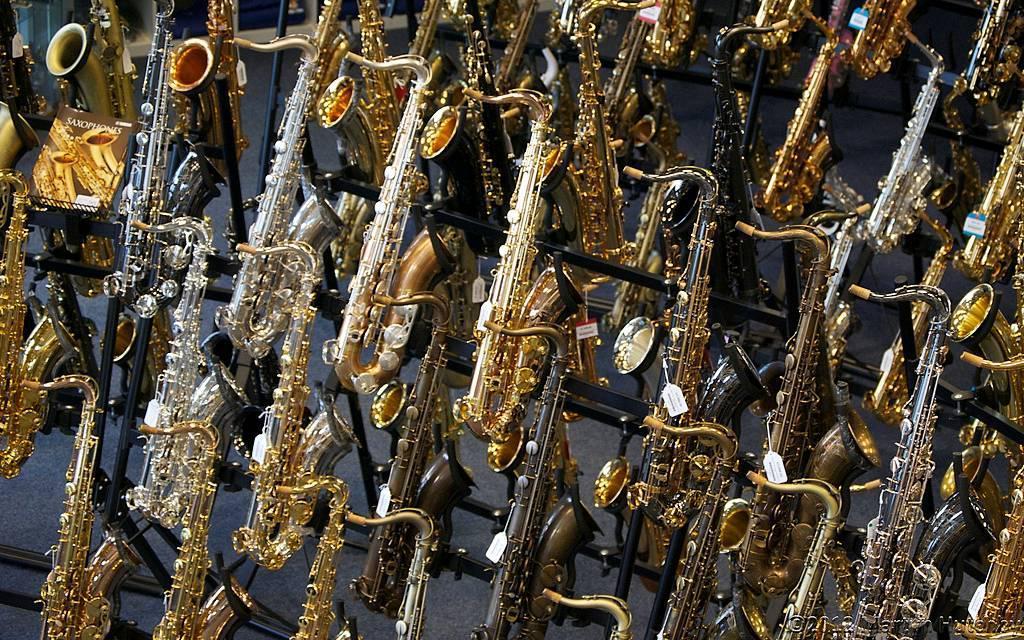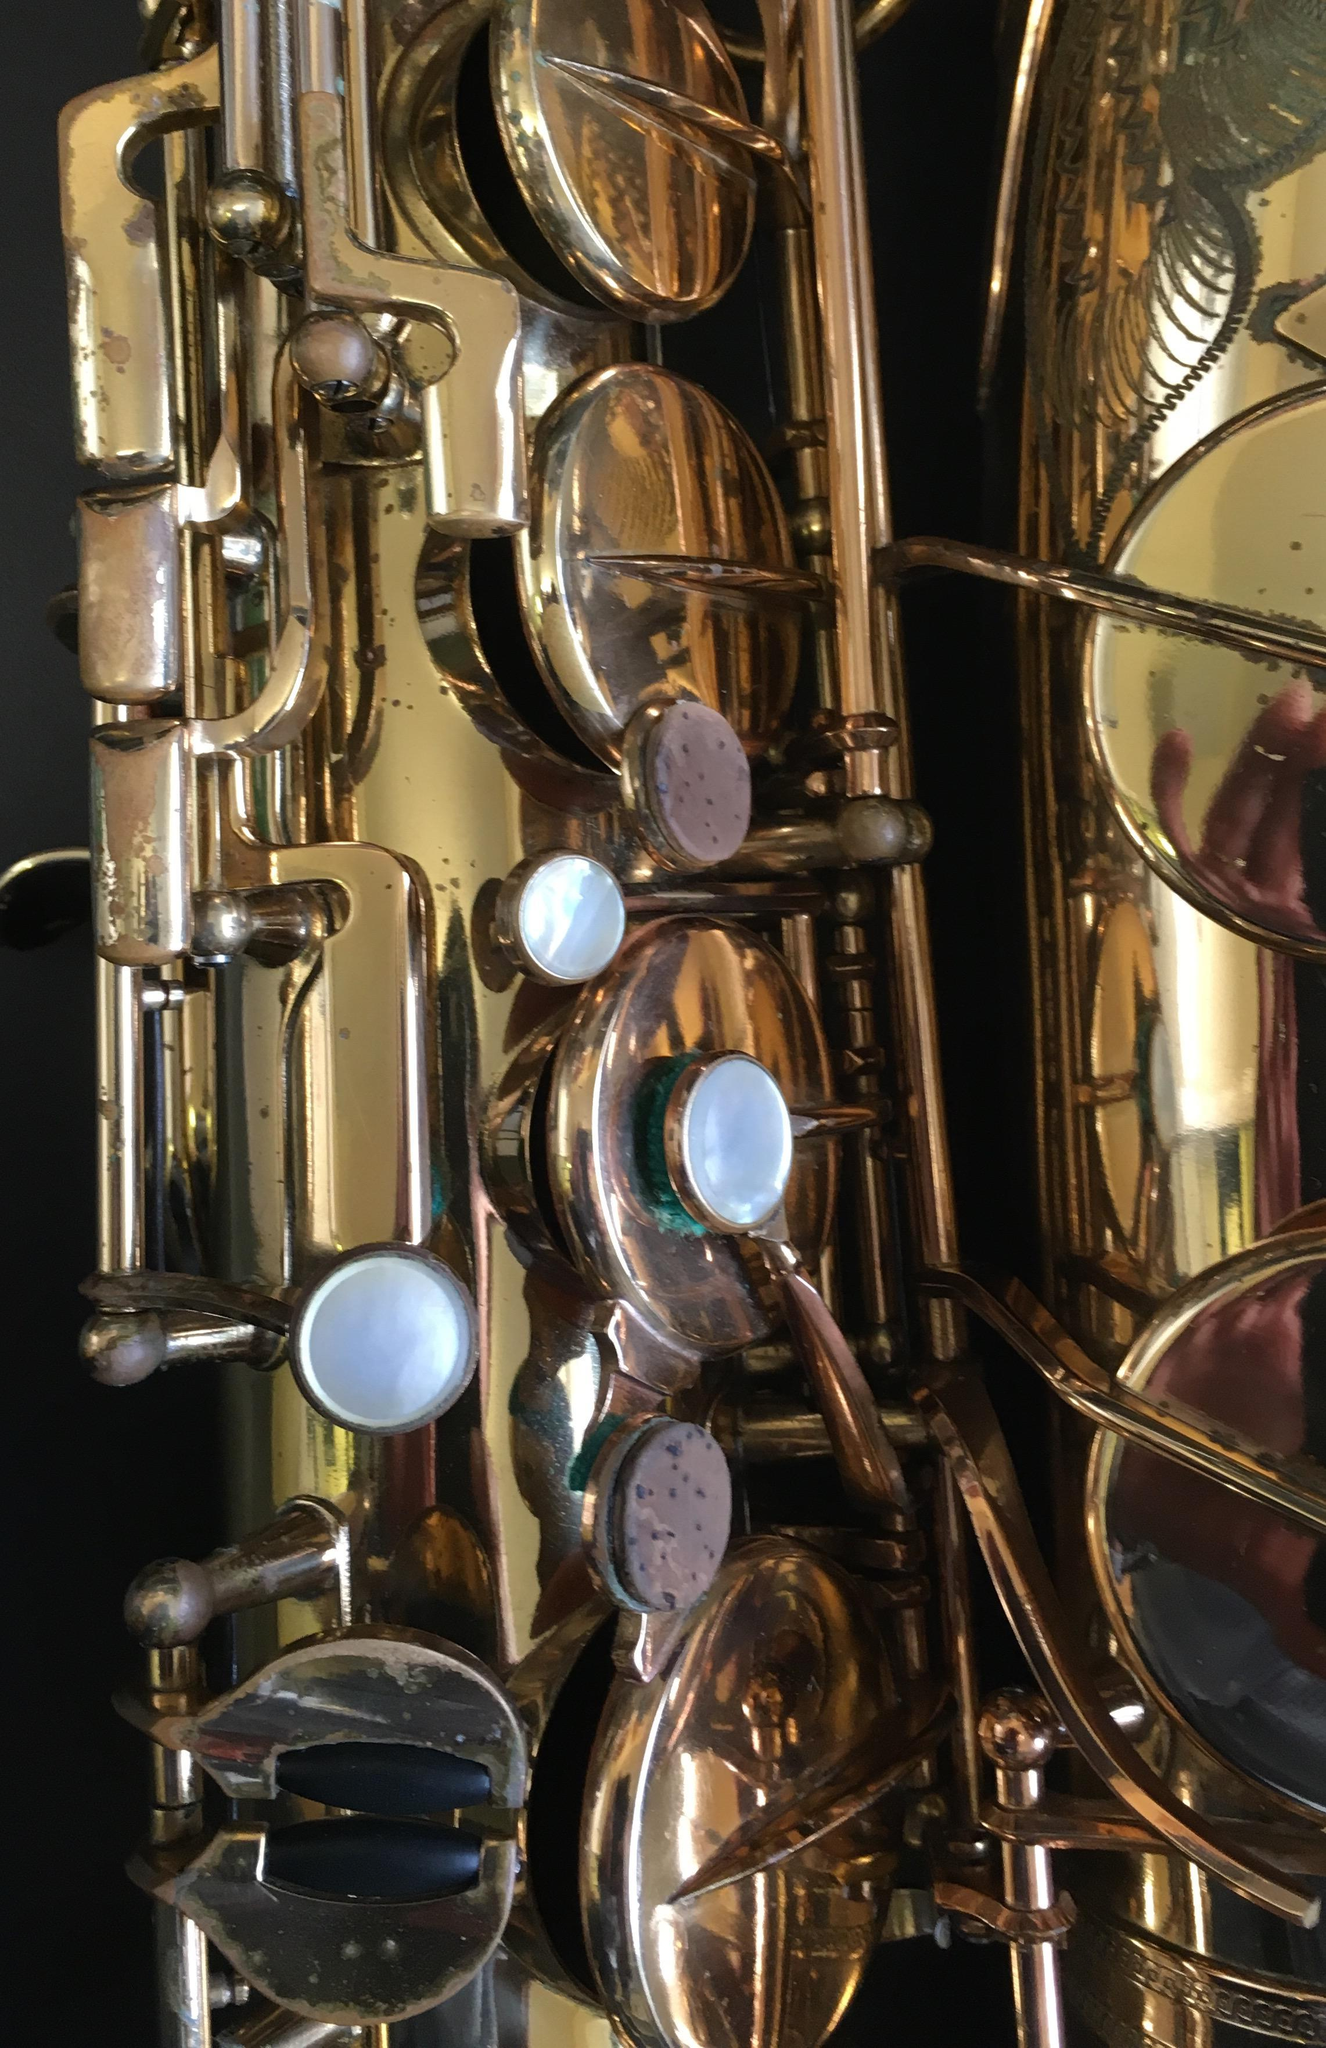The first image is the image on the left, the second image is the image on the right. Analyze the images presented: Is the assertion "A saxophone is sitting on a black stand in the image on the right." valid? Answer yes or no. No. The first image is the image on the left, the second image is the image on the right. Given the left and right images, does the statement "At least four musicians hold saxophones in one image." hold true? Answer yes or no. No. The first image is the image on the left, the second image is the image on the right. For the images shown, is this caption "Right image shows one saxophone and left image shows one row of saxophones." true? Answer yes or no. No. 